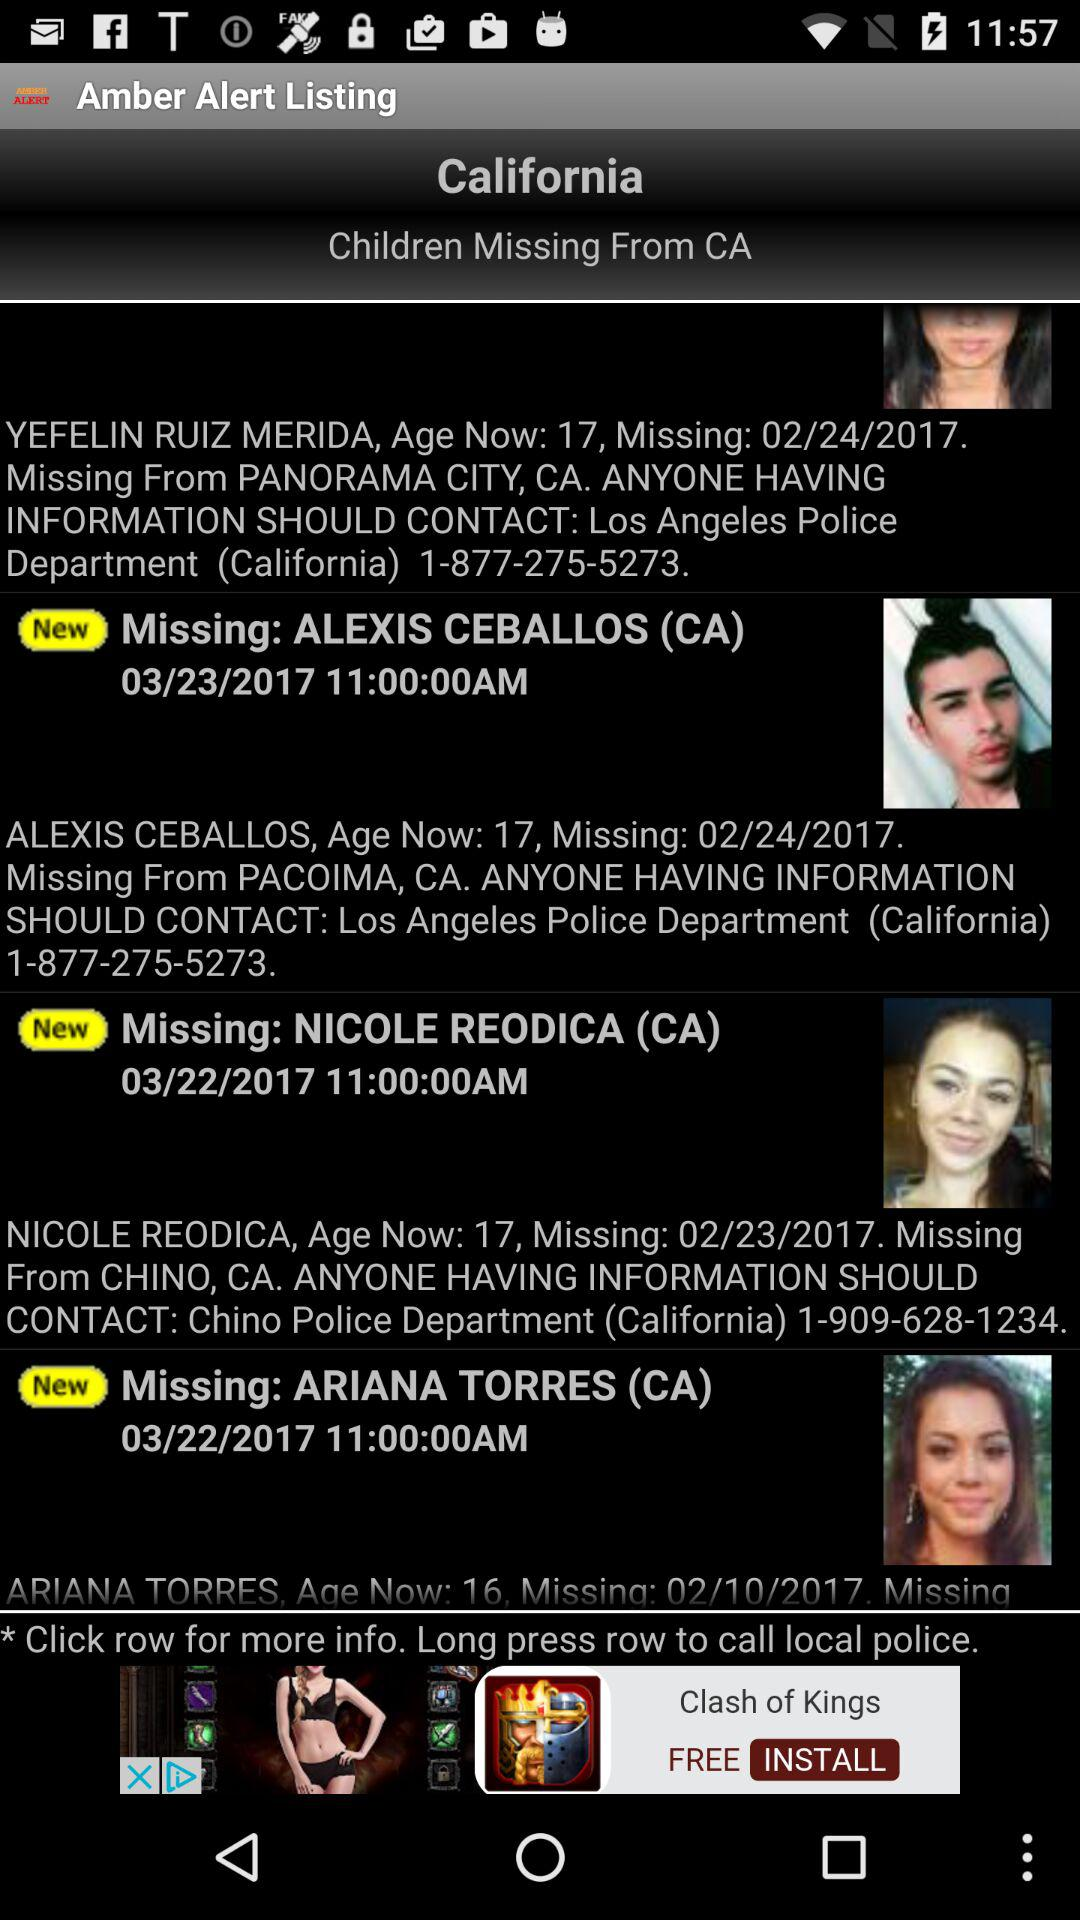When did Nicole Reodica go missing? Nicole Reodica went missing on February 23, 2017. 